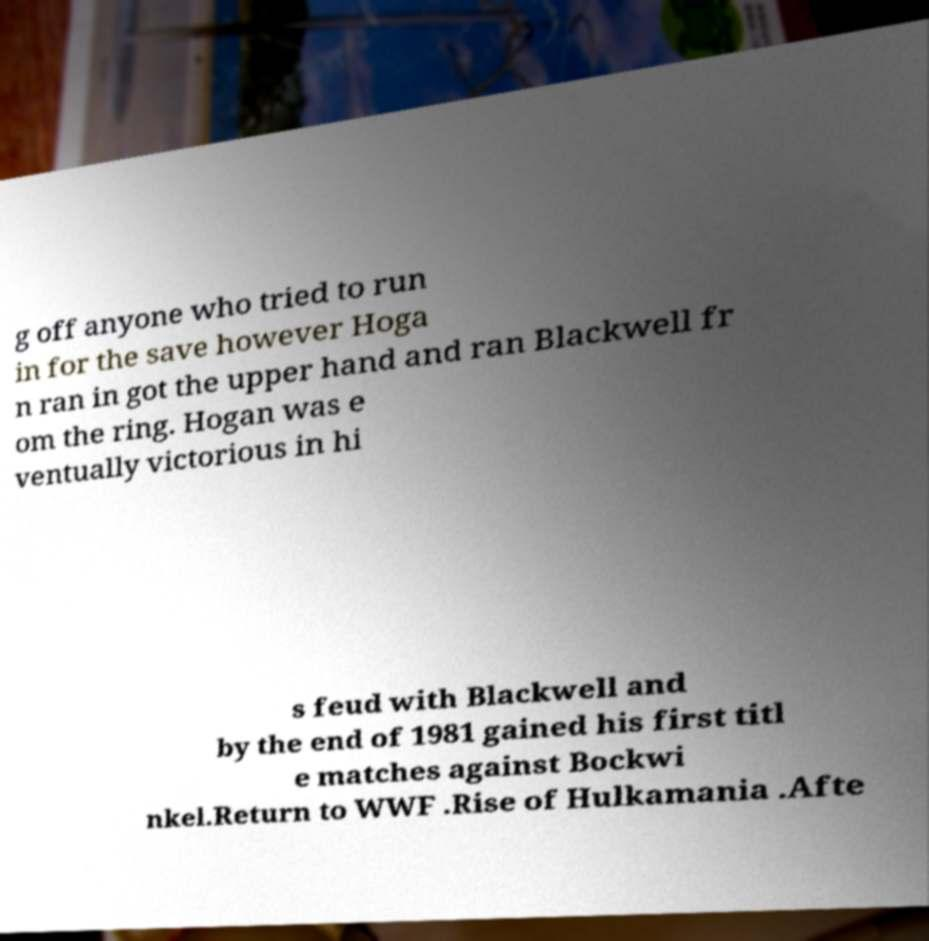There's text embedded in this image that I need extracted. Can you transcribe it verbatim? g off anyone who tried to run in for the save however Hoga n ran in got the upper hand and ran Blackwell fr om the ring. Hogan was e ventually victorious in hi s feud with Blackwell and by the end of 1981 gained his first titl e matches against Bockwi nkel.Return to WWF .Rise of Hulkamania .Afte 